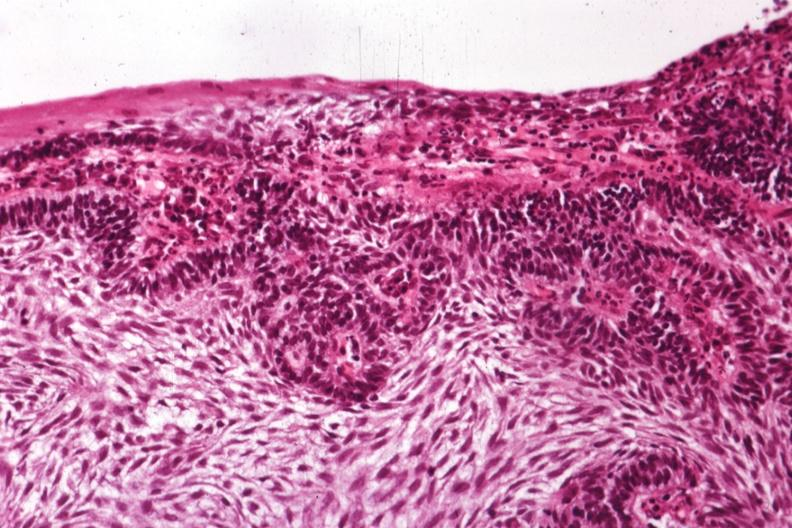s ameloblastoma present?
Answer the question using a single word or phrase. Yes 